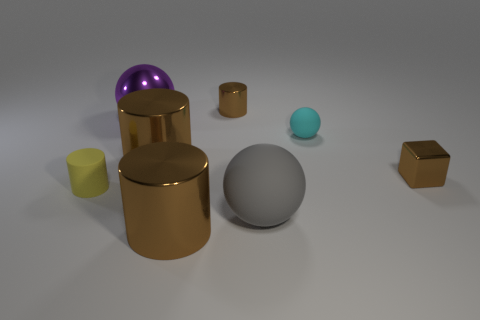There is a shiny cube that is the same color as the small metal cylinder; what size is it? The cube shares the same gold hue as the small metal cylinder and is of small size, comparable to the cylinder's dimensional scale. 